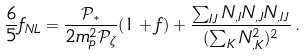<formula> <loc_0><loc_0><loc_500><loc_500>\frac { 6 } { 5 } f _ { N L } = \frac { \mathcal { P } _ { * } } { 2 m _ { p } ^ { 2 } \mathcal { P } _ { \zeta } } ( 1 + f ) + \frac { \sum _ { I J } N _ { , I } N _ { , J } N _ { , I J } } { ( \sum _ { K } N _ { , K } ^ { 2 } ) ^ { 2 } } \, .</formula> 